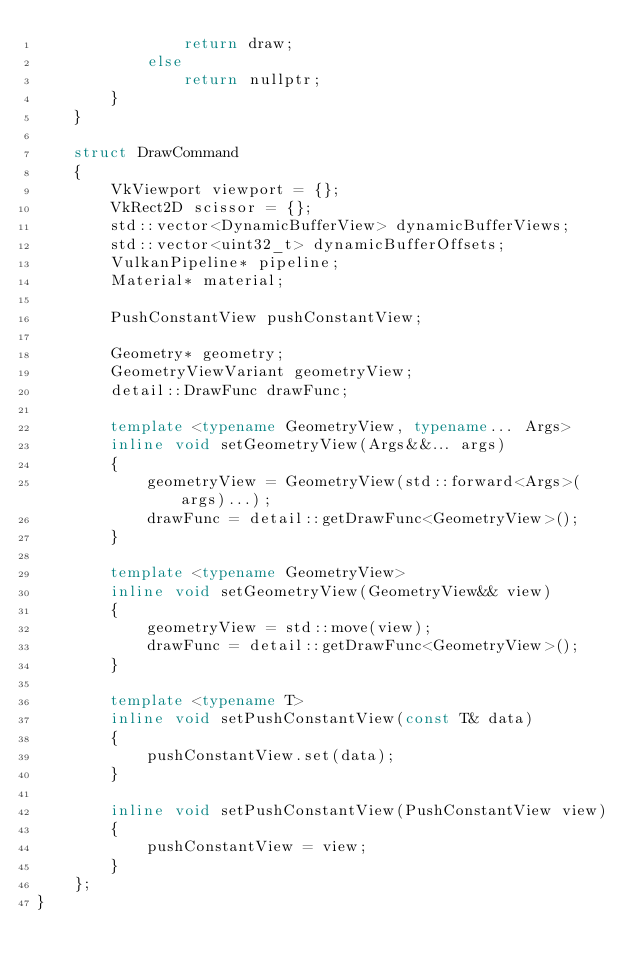Convert code to text. <code><loc_0><loc_0><loc_500><loc_500><_C++_>                return draw;
            else
                return nullptr;
        }
    }

    struct DrawCommand
    {
        VkViewport viewport = {};
        VkRect2D scissor = {};
        std::vector<DynamicBufferView> dynamicBufferViews;
        std::vector<uint32_t> dynamicBufferOffsets;
        VulkanPipeline* pipeline;
        Material* material;

        PushConstantView pushConstantView;

        Geometry* geometry;
        GeometryViewVariant geometryView;
        detail::DrawFunc drawFunc;

        template <typename GeometryView, typename... Args>
        inline void setGeometryView(Args&&... args)
        {
            geometryView = GeometryView(std::forward<Args>(args)...);
            drawFunc = detail::getDrawFunc<GeometryView>();
        }

        template <typename GeometryView>
        inline void setGeometryView(GeometryView&& view)
        {
            geometryView = std::move(view);
            drawFunc = detail::getDrawFunc<GeometryView>();
        }

        template <typename T>
        inline void setPushConstantView(const T& data)
        {
            pushConstantView.set(data);
        }

        inline void setPushConstantView(PushConstantView view)
        {
            pushConstantView = view;
        }
    };
}</code> 